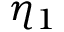<formula> <loc_0><loc_0><loc_500><loc_500>\eta _ { 1 }</formula> 